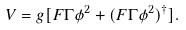Convert formula to latex. <formula><loc_0><loc_0><loc_500><loc_500>V = g [ F \Gamma \phi ^ { 2 } + ( F \Gamma \phi ^ { 2 } ) ^ { \dagger } ] .</formula> 